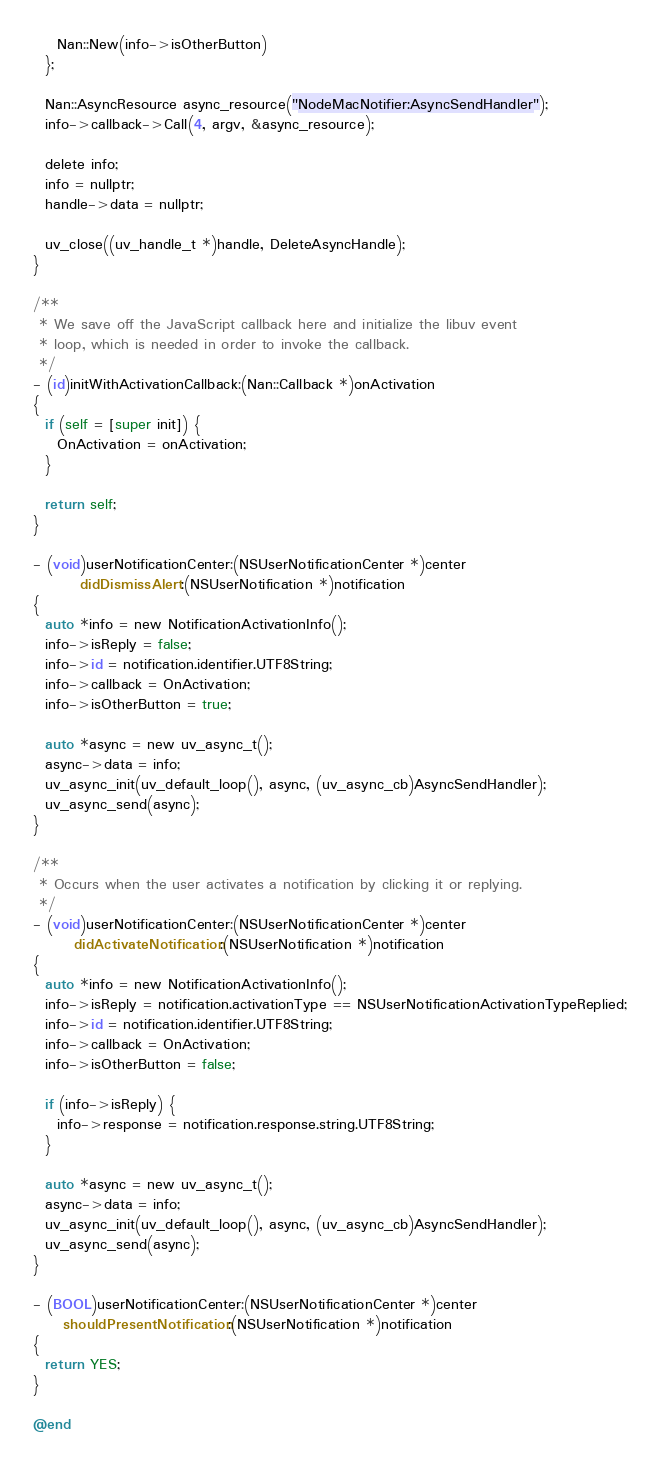<code> <loc_0><loc_0><loc_500><loc_500><_ObjectiveC_>    Nan::New(info->isOtherButton)
  };

  Nan::AsyncResource async_resource("NodeMacNotifier:AsyncSendHandler");
  info->callback->Call(4, argv, &async_resource);

  delete info;
  info = nullptr;
  handle->data = nullptr;

  uv_close((uv_handle_t *)handle, DeleteAsyncHandle);
}

/**
 * We save off the JavaScript callback here and initialize the libuv event
 * loop, which is needed in order to invoke the callback.
 */
- (id)initWithActivationCallback:(Nan::Callback *)onActivation
{
  if (self = [super init]) {
    OnActivation = onActivation;
  }

  return self;
}

- (void)userNotificationCenter:(NSUserNotificationCenter *)center
        didDismissAlert:(NSUserNotification *)notification
{
  auto *info = new NotificationActivationInfo();
  info->isReply = false;
  info->id = notification.identifier.UTF8String;
  info->callback = OnActivation;
  info->isOtherButton = true;

  auto *async = new uv_async_t();
  async->data = info;
  uv_async_init(uv_default_loop(), async, (uv_async_cb)AsyncSendHandler);
  uv_async_send(async);
}

/**
 * Occurs when the user activates a notification by clicking it or replying.
 */
- (void)userNotificationCenter:(NSUserNotificationCenter *)center
       didActivateNotification:(NSUserNotification *)notification
{
  auto *info = new NotificationActivationInfo();
  info->isReply = notification.activationType == NSUserNotificationActivationTypeReplied;
  info->id = notification.identifier.UTF8String;
  info->callback = OnActivation;
  info->isOtherButton = false;

  if (info->isReply) {
    info->response = notification.response.string.UTF8String;
  }

  auto *async = new uv_async_t();
  async->data = info;
  uv_async_init(uv_default_loop(), async, (uv_async_cb)AsyncSendHandler);
  uv_async_send(async);
}

- (BOOL)userNotificationCenter:(NSUserNotificationCenter *)center
     shouldPresentNotification:(NSUserNotification *)notification
{
  return YES;
}

@end
</code> 